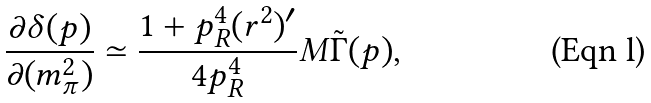Convert formula to latex. <formula><loc_0><loc_0><loc_500><loc_500>\frac { \partial \delta ( p ) } { \partial ( m _ { \pi } ^ { 2 } ) } \simeq \frac { 1 + p _ { R } ^ { 4 } ( r ^ { 2 } ) ^ { \prime } } { 4 p _ { R } ^ { 4 } } M \tilde { \Gamma } ( p ) ,</formula> 